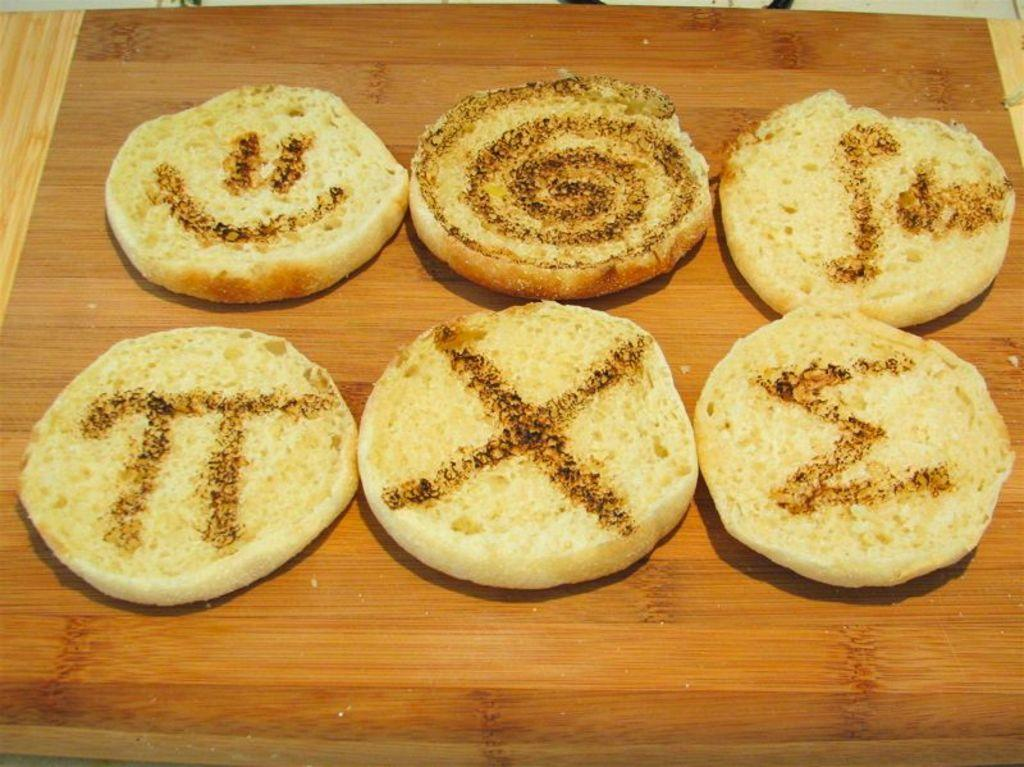What is present on the surface in the image? There is food placed on a surface in the image. What is the condition of the person's eye in the image? There is no person or eye present in the image; it only features food placed on a surface. 